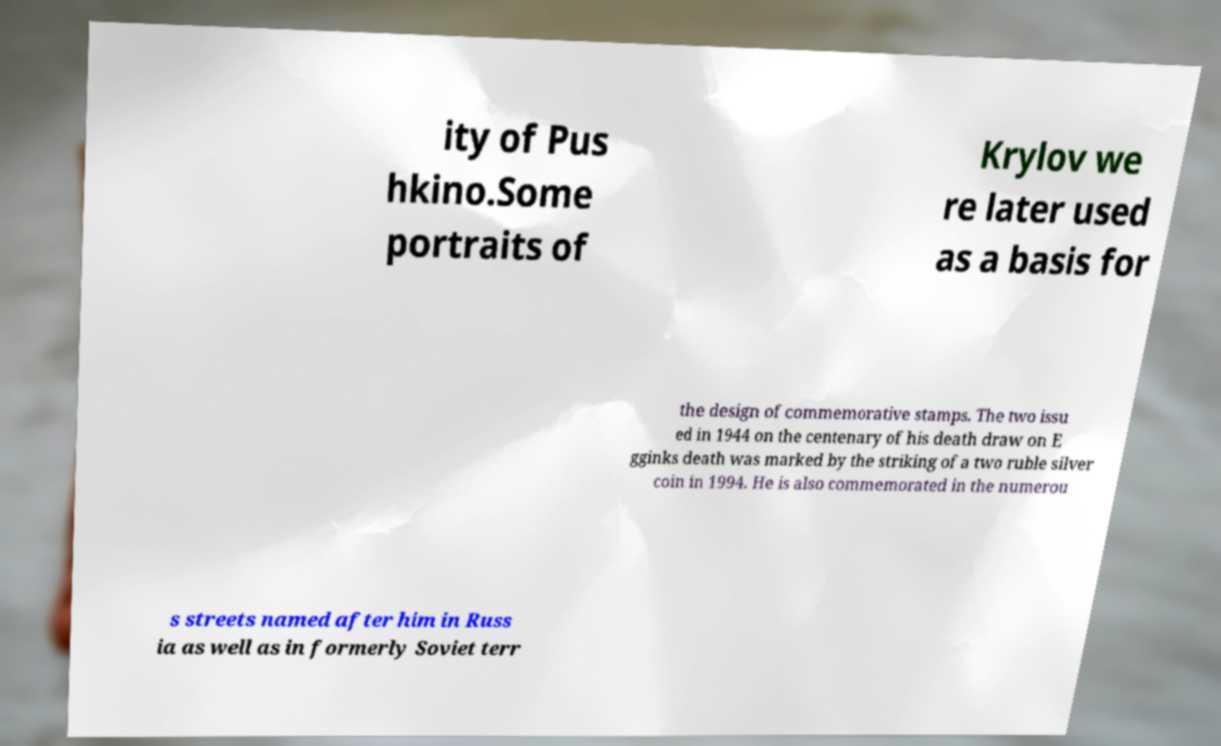There's text embedded in this image that I need extracted. Can you transcribe it verbatim? ity of Pus hkino.Some portraits of Krylov we re later used as a basis for the design of commemorative stamps. The two issu ed in 1944 on the centenary of his death draw on E gginks death was marked by the striking of a two ruble silver coin in 1994. He is also commemorated in the numerou s streets named after him in Russ ia as well as in formerly Soviet terr 